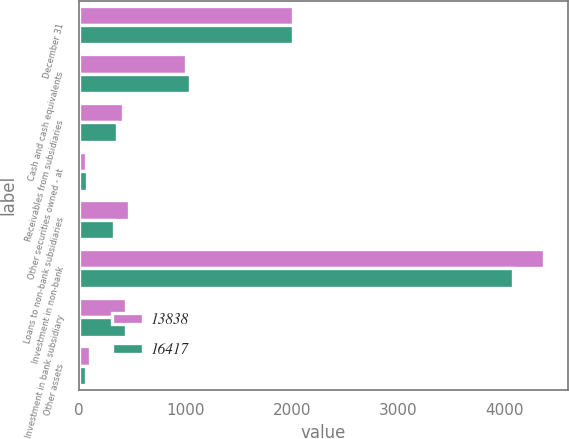Convert chart to OTSL. <chart><loc_0><loc_0><loc_500><loc_500><stacked_bar_chart><ecel><fcel>December 31<fcel>Cash and cash equivalents<fcel>Receivables from subsidiaries<fcel>Other securities owned - at<fcel>Loans to non-bank subsidiaries<fcel>Investment in non-bank<fcel>Investment in bank subsidiary<fcel>Other assets<nl><fcel>13838<fcel>2015<fcel>1007<fcel>419<fcel>65<fcel>468<fcel>4374<fcel>443.5<fcel>101<nl><fcel>16417<fcel>2014<fcel>1043<fcel>360<fcel>74<fcel>327<fcel>4083<fcel>443.5<fcel>68<nl></chart> 